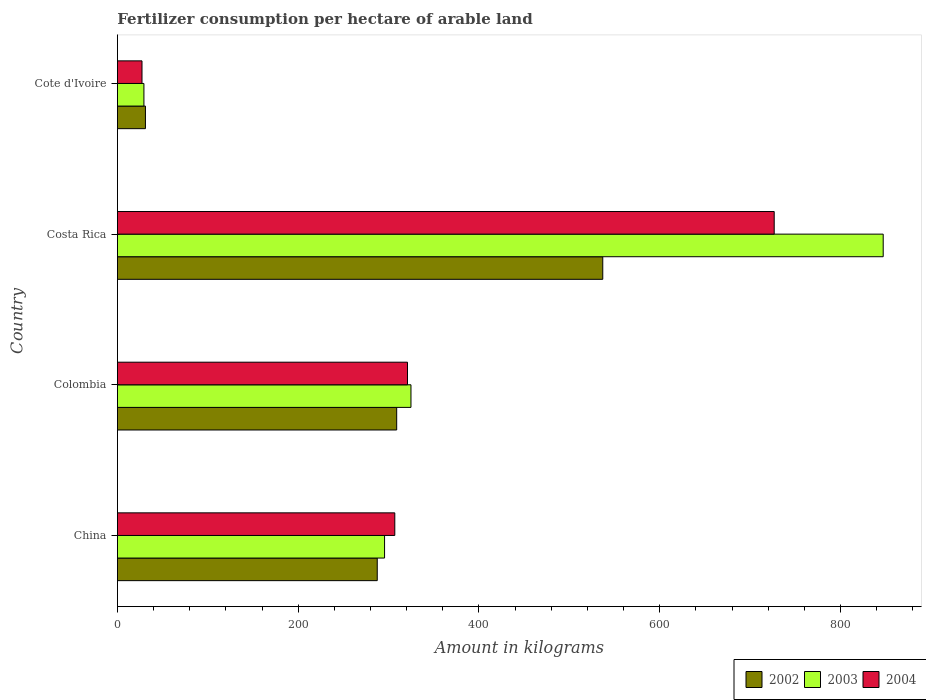How many groups of bars are there?
Provide a succinct answer. 4. Are the number of bars per tick equal to the number of legend labels?
Your response must be concise. Yes. What is the label of the 1st group of bars from the top?
Provide a short and direct response. Cote d'Ivoire. In how many cases, is the number of bars for a given country not equal to the number of legend labels?
Offer a very short reply. 0. What is the amount of fertilizer consumption in 2004 in Costa Rica?
Provide a short and direct response. 726.7. Across all countries, what is the maximum amount of fertilizer consumption in 2003?
Ensure brevity in your answer.  847.29. Across all countries, what is the minimum amount of fertilizer consumption in 2004?
Ensure brevity in your answer.  27.22. In which country was the amount of fertilizer consumption in 2004 minimum?
Your answer should be very brief. Cote d'Ivoire. What is the total amount of fertilizer consumption in 2003 in the graph?
Ensure brevity in your answer.  1497.04. What is the difference between the amount of fertilizer consumption in 2003 in Costa Rica and that in Cote d'Ivoire?
Your answer should be very brief. 817.95. What is the difference between the amount of fertilizer consumption in 2002 in China and the amount of fertilizer consumption in 2004 in Cote d'Ivoire?
Provide a short and direct response. 260.28. What is the average amount of fertilizer consumption in 2002 per country?
Give a very brief answer. 291.13. What is the difference between the amount of fertilizer consumption in 2004 and amount of fertilizer consumption in 2002 in Costa Rica?
Your response must be concise. 189.69. In how many countries, is the amount of fertilizer consumption in 2003 greater than 240 kg?
Offer a terse response. 3. What is the ratio of the amount of fertilizer consumption in 2004 in Colombia to that in Cote d'Ivoire?
Ensure brevity in your answer.  11.79. What is the difference between the highest and the second highest amount of fertilizer consumption in 2004?
Provide a short and direct response. 405.73. What is the difference between the highest and the lowest amount of fertilizer consumption in 2002?
Offer a terse response. 505.99. In how many countries, is the amount of fertilizer consumption in 2002 greater than the average amount of fertilizer consumption in 2002 taken over all countries?
Ensure brevity in your answer.  2. Is the sum of the amount of fertilizer consumption in 2003 in Colombia and Cote d'Ivoire greater than the maximum amount of fertilizer consumption in 2002 across all countries?
Your answer should be very brief. No. How many bars are there?
Your response must be concise. 12. Are all the bars in the graph horizontal?
Your answer should be compact. Yes. How many countries are there in the graph?
Your answer should be very brief. 4. What is the difference between two consecutive major ticks on the X-axis?
Give a very brief answer. 200. Does the graph contain any zero values?
Provide a short and direct response. No. Does the graph contain grids?
Give a very brief answer. No. How many legend labels are there?
Make the answer very short. 3. What is the title of the graph?
Offer a terse response. Fertilizer consumption per hectare of arable land. What is the label or title of the X-axis?
Your answer should be very brief. Amount in kilograms. What is the label or title of the Y-axis?
Keep it short and to the point. Country. What is the Amount in kilograms in 2002 in China?
Make the answer very short. 287.5. What is the Amount in kilograms of 2003 in China?
Keep it short and to the point. 295.6. What is the Amount in kilograms of 2004 in China?
Ensure brevity in your answer.  306.92. What is the Amount in kilograms of 2002 in Colombia?
Provide a short and direct response. 309. What is the Amount in kilograms of 2003 in Colombia?
Give a very brief answer. 324.81. What is the Amount in kilograms of 2004 in Colombia?
Keep it short and to the point. 320.96. What is the Amount in kilograms of 2002 in Costa Rica?
Give a very brief answer. 537.01. What is the Amount in kilograms of 2003 in Costa Rica?
Offer a very short reply. 847.29. What is the Amount in kilograms in 2004 in Costa Rica?
Offer a very short reply. 726.7. What is the Amount in kilograms in 2002 in Cote d'Ivoire?
Keep it short and to the point. 31.02. What is the Amount in kilograms in 2003 in Cote d'Ivoire?
Give a very brief answer. 29.35. What is the Amount in kilograms in 2004 in Cote d'Ivoire?
Your answer should be compact. 27.22. Across all countries, what is the maximum Amount in kilograms in 2002?
Your response must be concise. 537.01. Across all countries, what is the maximum Amount in kilograms of 2003?
Provide a short and direct response. 847.29. Across all countries, what is the maximum Amount in kilograms of 2004?
Your response must be concise. 726.7. Across all countries, what is the minimum Amount in kilograms of 2002?
Your answer should be compact. 31.02. Across all countries, what is the minimum Amount in kilograms of 2003?
Your answer should be compact. 29.35. Across all countries, what is the minimum Amount in kilograms in 2004?
Your response must be concise. 27.22. What is the total Amount in kilograms of 2002 in the graph?
Your response must be concise. 1164.53. What is the total Amount in kilograms of 2003 in the graph?
Make the answer very short. 1497.04. What is the total Amount in kilograms in 2004 in the graph?
Your answer should be very brief. 1381.79. What is the difference between the Amount in kilograms in 2002 in China and that in Colombia?
Ensure brevity in your answer.  -21.5. What is the difference between the Amount in kilograms of 2003 in China and that in Colombia?
Make the answer very short. -29.21. What is the difference between the Amount in kilograms of 2004 in China and that in Colombia?
Ensure brevity in your answer.  -14.05. What is the difference between the Amount in kilograms of 2002 in China and that in Costa Rica?
Your answer should be very brief. -249.51. What is the difference between the Amount in kilograms in 2003 in China and that in Costa Rica?
Make the answer very short. -551.7. What is the difference between the Amount in kilograms of 2004 in China and that in Costa Rica?
Your answer should be compact. -419.78. What is the difference between the Amount in kilograms in 2002 in China and that in Cote d'Ivoire?
Offer a terse response. 256.48. What is the difference between the Amount in kilograms of 2003 in China and that in Cote d'Ivoire?
Provide a succinct answer. 266.25. What is the difference between the Amount in kilograms of 2004 in China and that in Cote d'Ivoire?
Offer a very short reply. 279.7. What is the difference between the Amount in kilograms of 2002 in Colombia and that in Costa Rica?
Your response must be concise. -228.01. What is the difference between the Amount in kilograms in 2003 in Colombia and that in Costa Rica?
Keep it short and to the point. -522.48. What is the difference between the Amount in kilograms in 2004 in Colombia and that in Costa Rica?
Keep it short and to the point. -405.73. What is the difference between the Amount in kilograms in 2002 in Colombia and that in Cote d'Ivoire?
Offer a terse response. 277.98. What is the difference between the Amount in kilograms of 2003 in Colombia and that in Cote d'Ivoire?
Ensure brevity in your answer.  295.46. What is the difference between the Amount in kilograms in 2004 in Colombia and that in Cote d'Ivoire?
Provide a succinct answer. 293.74. What is the difference between the Amount in kilograms of 2002 in Costa Rica and that in Cote d'Ivoire?
Provide a succinct answer. 505.99. What is the difference between the Amount in kilograms in 2003 in Costa Rica and that in Cote d'Ivoire?
Your answer should be very brief. 817.95. What is the difference between the Amount in kilograms of 2004 in Costa Rica and that in Cote d'Ivoire?
Provide a short and direct response. 699.48. What is the difference between the Amount in kilograms in 2002 in China and the Amount in kilograms in 2003 in Colombia?
Offer a very short reply. -37.31. What is the difference between the Amount in kilograms in 2002 in China and the Amount in kilograms in 2004 in Colombia?
Your response must be concise. -33.46. What is the difference between the Amount in kilograms of 2003 in China and the Amount in kilograms of 2004 in Colombia?
Offer a very short reply. -25.37. What is the difference between the Amount in kilograms of 2002 in China and the Amount in kilograms of 2003 in Costa Rica?
Your response must be concise. -559.79. What is the difference between the Amount in kilograms in 2002 in China and the Amount in kilograms in 2004 in Costa Rica?
Offer a terse response. -439.19. What is the difference between the Amount in kilograms in 2003 in China and the Amount in kilograms in 2004 in Costa Rica?
Make the answer very short. -431.1. What is the difference between the Amount in kilograms in 2002 in China and the Amount in kilograms in 2003 in Cote d'Ivoire?
Your answer should be very brief. 258.16. What is the difference between the Amount in kilograms in 2002 in China and the Amount in kilograms in 2004 in Cote d'Ivoire?
Your answer should be very brief. 260.28. What is the difference between the Amount in kilograms in 2003 in China and the Amount in kilograms in 2004 in Cote d'Ivoire?
Make the answer very short. 268.38. What is the difference between the Amount in kilograms of 2002 in Colombia and the Amount in kilograms of 2003 in Costa Rica?
Your answer should be compact. -538.29. What is the difference between the Amount in kilograms in 2002 in Colombia and the Amount in kilograms in 2004 in Costa Rica?
Make the answer very short. -417.69. What is the difference between the Amount in kilograms of 2003 in Colombia and the Amount in kilograms of 2004 in Costa Rica?
Keep it short and to the point. -401.89. What is the difference between the Amount in kilograms of 2002 in Colombia and the Amount in kilograms of 2003 in Cote d'Ivoire?
Offer a very short reply. 279.66. What is the difference between the Amount in kilograms in 2002 in Colombia and the Amount in kilograms in 2004 in Cote d'Ivoire?
Offer a very short reply. 281.78. What is the difference between the Amount in kilograms of 2003 in Colombia and the Amount in kilograms of 2004 in Cote d'Ivoire?
Offer a terse response. 297.59. What is the difference between the Amount in kilograms in 2002 in Costa Rica and the Amount in kilograms in 2003 in Cote d'Ivoire?
Your answer should be compact. 507.66. What is the difference between the Amount in kilograms of 2002 in Costa Rica and the Amount in kilograms of 2004 in Cote d'Ivoire?
Provide a succinct answer. 509.79. What is the difference between the Amount in kilograms of 2003 in Costa Rica and the Amount in kilograms of 2004 in Cote d'Ivoire?
Your answer should be very brief. 820.07. What is the average Amount in kilograms in 2002 per country?
Give a very brief answer. 291.13. What is the average Amount in kilograms of 2003 per country?
Make the answer very short. 374.26. What is the average Amount in kilograms in 2004 per country?
Make the answer very short. 345.45. What is the difference between the Amount in kilograms of 2002 and Amount in kilograms of 2003 in China?
Give a very brief answer. -8.09. What is the difference between the Amount in kilograms in 2002 and Amount in kilograms in 2004 in China?
Offer a terse response. -19.42. What is the difference between the Amount in kilograms in 2003 and Amount in kilograms in 2004 in China?
Your answer should be very brief. -11.32. What is the difference between the Amount in kilograms in 2002 and Amount in kilograms in 2003 in Colombia?
Ensure brevity in your answer.  -15.81. What is the difference between the Amount in kilograms in 2002 and Amount in kilograms in 2004 in Colombia?
Your response must be concise. -11.96. What is the difference between the Amount in kilograms of 2003 and Amount in kilograms of 2004 in Colombia?
Provide a short and direct response. 3.85. What is the difference between the Amount in kilograms of 2002 and Amount in kilograms of 2003 in Costa Rica?
Give a very brief answer. -310.28. What is the difference between the Amount in kilograms of 2002 and Amount in kilograms of 2004 in Costa Rica?
Provide a short and direct response. -189.69. What is the difference between the Amount in kilograms of 2003 and Amount in kilograms of 2004 in Costa Rica?
Your answer should be very brief. 120.6. What is the difference between the Amount in kilograms in 2002 and Amount in kilograms in 2003 in Cote d'Ivoire?
Your answer should be compact. 1.67. What is the difference between the Amount in kilograms in 2003 and Amount in kilograms in 2004 in Cote d'Ivoire?
Give a very brief answer. 2.13. What is the ratio of the Amount in kilograms of 2002 in China to that in Colombia?
Offer a terse response. 0.93. What is the ratio of the Amount in kilograms of 2003 in China to that in Colombia?
Your answer should be compact. 0.91. What is the ratio of the Amount in kilograms in 2004 in China to that in Colombia?
Make the answer very short. 0.96. What is the ratio of the Amount in kilograms in 2002 in China to that in Costa Rica?
Give a very brief answer. 0.54. What is the ratio of the Amount in kilograms of 2003 in China to that in Costa Rica?
Make the answer very short. 0.35. What is the ratio of the Amount in kilograms of 2004 in China to that in Costa Rica?
Ensure brevity in your answer.  0.42. What is the ratio of the Amount in kilograms of 2002 in China to that in Cote d'Ivoire?
Offer a very short reply. 9.27. What is the ratio of the Amount in kilograms of 2003 in China to that in Cote d'Ivoire?
Offer a terse response. 10.07. What is the ratio of the Amount in kilograms in 2004 in China to that in Cote d'Ivoire?
Make the answer very short. 11.28. What is the ratio of the Amount in kilograms of 2002 in Colombia to that in Costa Rica?
Provide a succinct answer. 0.58. What is the ratio of the Amount in kilograms of 2003 in Colombia to that in Costa Rica?
Your answer should be very brief. 0.38. What is the ratio of the Amount in kilograms in 2004 in Colombia to that in Costa Rica?
Offer a very short reply. 0.44. What is the ratio of the Amount in kilograms in 2002 in Colombia to that in Cote d'Ivoire?
Ensure brevity in your answer.  9.96. What is the ratio of the Amount in kilograms of 2003 in Colombia to that in Cote d'Ivoire?
Your answer should be compact. 11.07. What is the ratio of the Amount in kilograms in 2004 in Colombia to that in Cote d'Ivoire?
Offer a terse response. 11.79. What is the ratio of the Amount in kilograms in 2002 in Costa Rica to that in Cote d'Ivoire?
Provide a succinct answer. 17.31. What is the ratio of the Amount in kilograms in 2003 in Costa Rica to that in Cote d'Ivoire?
Offer a terse response. 28.87. What is the ratio of the Amount in kilograms of 2004 in Costa Rica to that in Cote d'Ivoire?
Your response must be concise. 26.7. What is the difference between the highest and the second highest Amount in kilograms of 2002?
Your answer should be compact. 228.01. What is the difference between the highest and the second highest Amount in kilograms of 2003?
Offer a terse response. 522.48. What is the difference between the highest and the second highest Amount in kilograms in 2004?
Your answer should be very brief. 405.73. What is the difference between the highest and the lowest Amount in kilograms in 2002?
Give a very brief answer. 505.99. What is the difference between the highest and the lowest Amount in kilograms in 2003?
Give a very brief answer. 817.95. What is the difference between the highest and the lowest Amount in kilograms of 2004?
Keep it short and to the point. 699.48. 